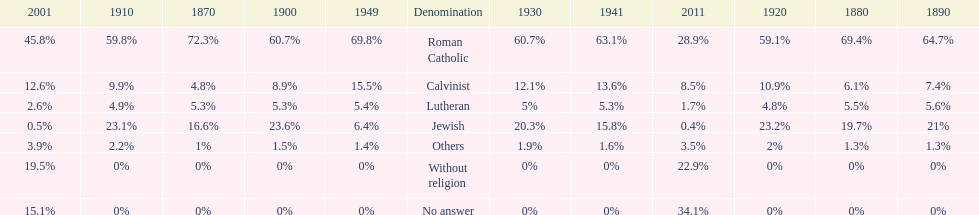Which denomination held the largest percentage in 1880? Roman Catholic. 